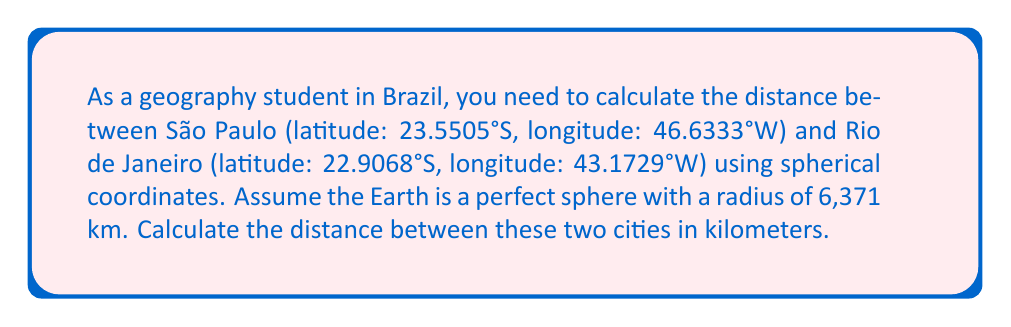Provide a solution to this math problem. To solve this problem, we'll use the spherical law of cosines formula. Let's follow these steps:

1. Convert the latitudes and longitudes to radians:
   São Paulo: $\phi_1 = -23.5505° \times \frac{\pi}{180} = -0.4110$ rad
              $\lambda_1 = -46.6333° \times \frac{\pi}{180} = -0.8138$ rad
   Rio de Janeiro: $\phi_2 = -22.9068° \times \frac{\pi}{180} = -0.3998$ rad
                   $\lambda_2 = -43.1729° \times \frac{\pi}{180} = -0.7534$ rad

2. Calculate the central angle $\Delta\sigma$ using the spherical law of cosines:
   $$\Delta\sigma = \arccos(\sin\phi_1 \sin\phi_2 + \cos\phi_1 \cos\phi_2 \cos(\lambda_2 - \lambda_1))$$

3. Substitute the values:
   $$\Delta\sigma = \arccos(\sin(-0.4110) \sin(-0.3998) + \cos(-0.4110) \cos(-0.3998) \cos(-0.7534 - (-0.8138)))$$

4. Evaluate:
   $$\Delta\sigma = \arccos(0.9997) = 0.0241 \text{ rad}$$

5. Calculate the distance $d$ using the formula $d = R \Delta\sigma$, where $R$ is the Earth's radius:
   $$d = 6371 \times 0.0241 = 153.54 \text{ km}$$
Answer: 153.54 km 